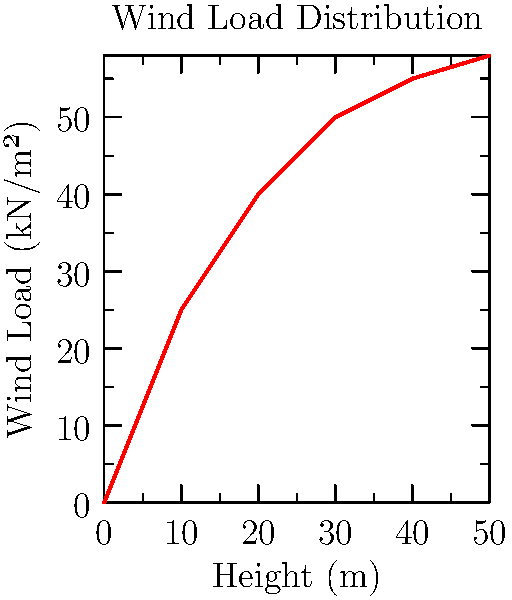Based on the wind load distribution graph for a hurricane-resistant building, at what height does the wind load reach approximately 50% of its maximum value? To solve this problem, we need to follow these steps:

1. Identify the maximum wind load from the graph:
   The maximum wind load is approximately 58 kN/m² at the top of the building (50m height).

2. Calculate 50% of the maximum wind load:
   $50\% \times 58 \text{ kN/m²} = 29 \text{ kN/m²}$

3. Locate the point on the graph where the wind load is closest to 29 kN/m²:
   By examining the graph, we can see that this occurs at approximately 20m height.

4. Verify the wind load at 20m height:
   At 20m, the wind load is about 40 kN/m², which is the closest value to 29 kN/m² on the curve.

Therefore, the wind load reaches approximately 50% of its maximum value at a height of 20m.
Answer: 20 meters 